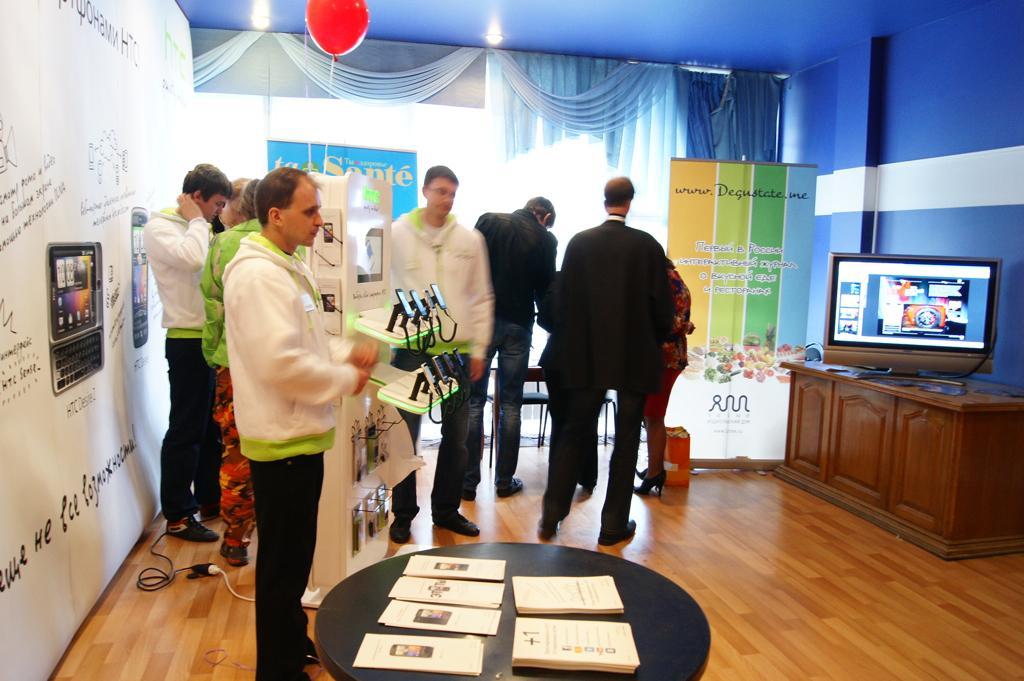Can you describe this image briefly? In this image we can see persons standing on the floor. In additional to this we can see television set placed on the table, advertisements, balloon, curtains, walls, books and mobile phones placed on the stands. 